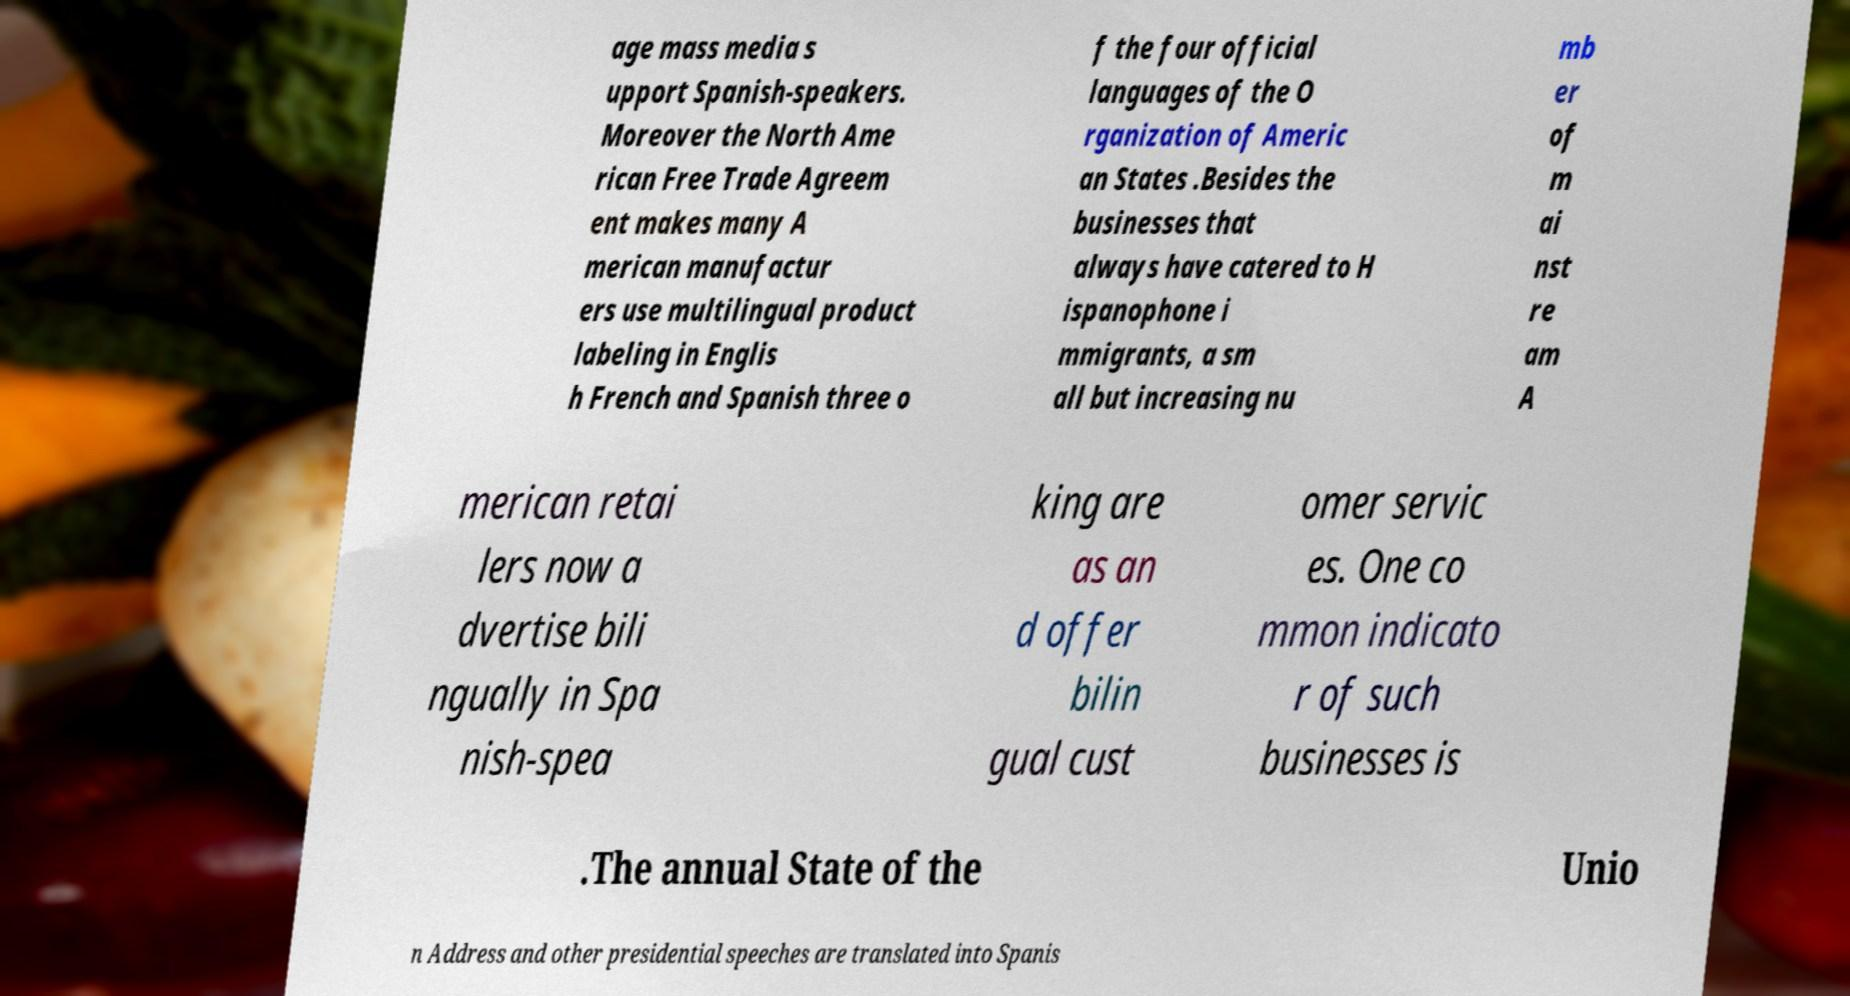I need the written content from this picture converted into text. Can you do that? age mass media s upport Spanish-speakers. Moreover the North Ame rican Free Trade Agreem ent makes many A merican manufactur ers use multilingual product labeling in Englis h French and Spanish three o f the four official languages of the O rganization of Americ an States .Besides the businesses that always have catered to H ispanophone i mmigrants, a sm all but increasing nu mb er of m ai nst re am A merican retai lers now a dvertise bili ngually in Spa nish-spea king are as an d offer bilin gual cust omer servic es. One co mmon indicato r of such businesses is .The annual State of the Unio n Address and other presidential speeches are translated into Spanis 